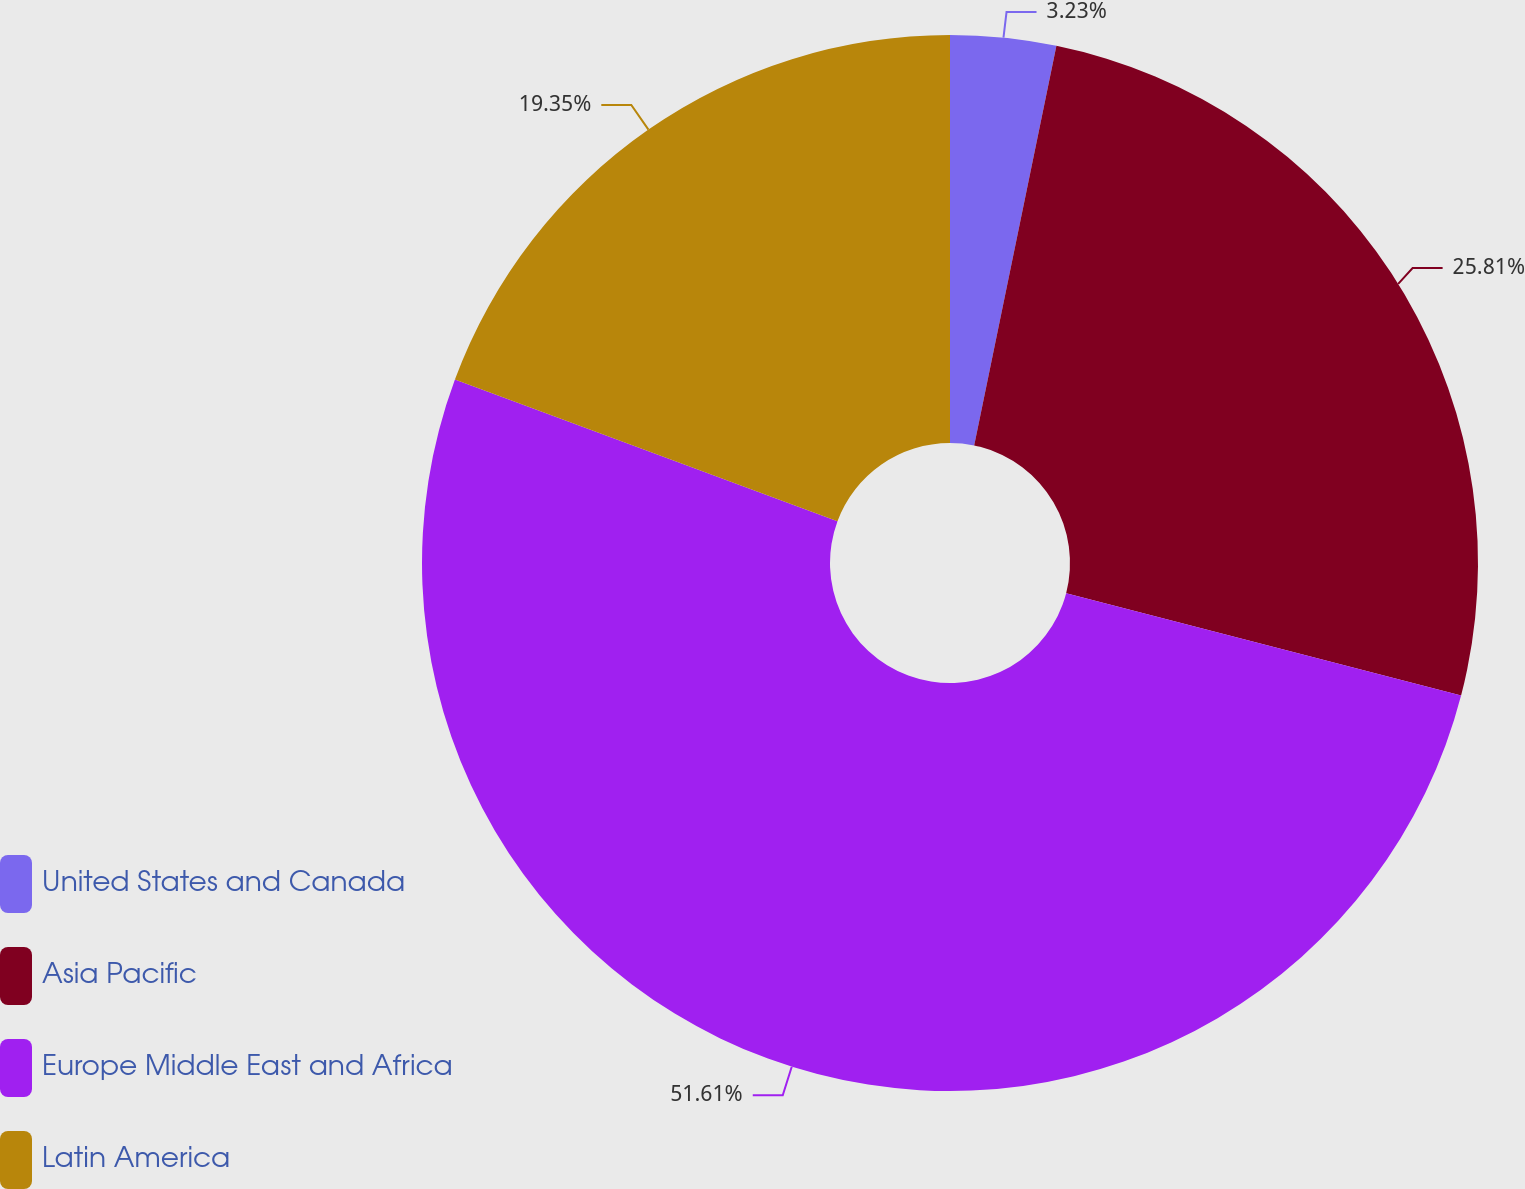<chart> <loc_0><loc_0><loc_500><loc_500><pie_chart><fcel>United States and Canada<fcel>Asia Pacific<fcel>Europe Middle East and Africa<fcel>Latin America<nl><fcel>3.23%<fcel>25.81%<fcel>51.61%<fcel>19.35%<nl></chart> 